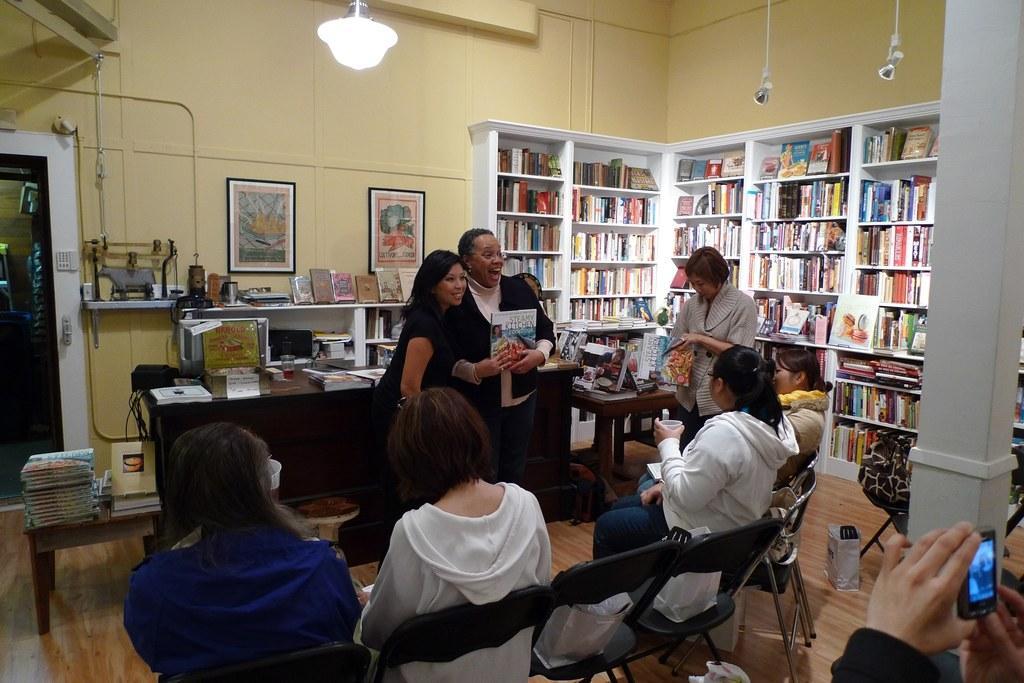Could you give a brief overview of what you see in this image? In this picture I can observe some people in this room. Some of them are sitting on the chairs. I can observe a light hanging to the ceiling on the top of the picture. On the right side there is a bookshelf. In the background I can observe some photo frames on the wall. 